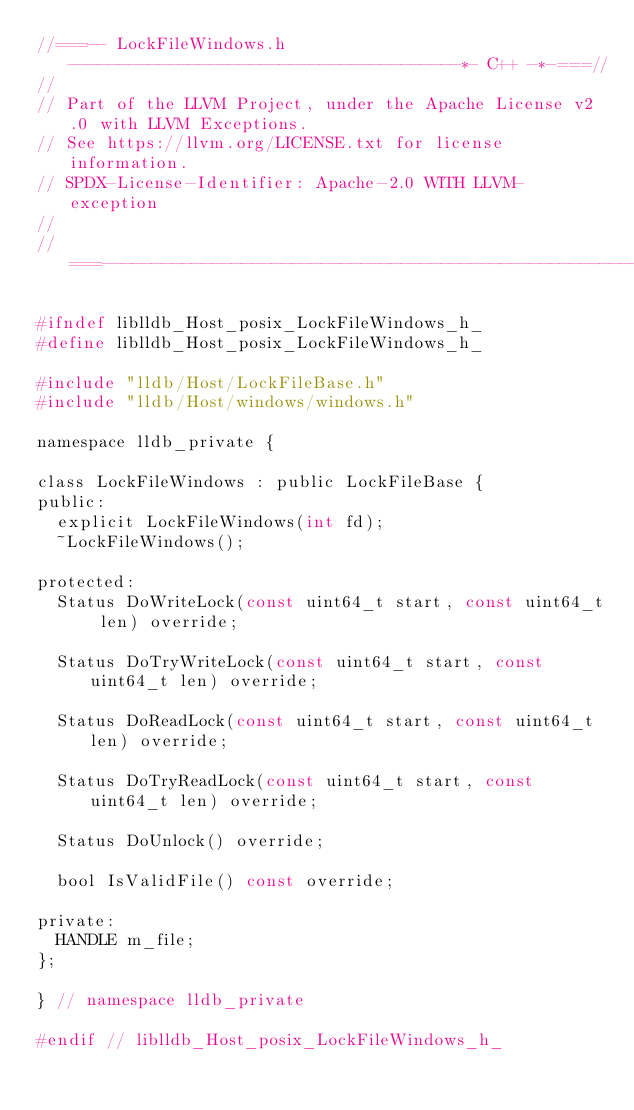<code> <loc_0><loc_0><loc_500><loc_500><_C_>//===-- LockFileWindows.h ---------------------------------------*- C++ -*-===//
//
// Part of the LLVM Project, under the Apache License v2.0 with LLVM Exceptions.
// See https://llvm.org/LICENSE.txt for license information.
// SPDX-License-Identifier: Apache-2.0 WITH LLVM-exception
//
//===----------------------------------------------------------------------===//

#ifndef liblldb_Host_posix_LockFileWindows_h_
#define liblldb_Host_posix_LockFileWindows_h_

#include "lldb/Host/LockFileBase.h"
#include "lldb/Host/windows/windows.h"

namespace lldb_private {

class LockFileWindows : public LockFileBase {
public:
  explicit LockFileWindows(int fd);
  ~LockFileWindows();

protected:
  Status DoWriteLock(const uint64_t start, const uint64_t len) override;

  Status DoTryWriteLock(const uint64_t start, const uint64_t len) override;

  Status DoReadLock(const uint64_t start, const uint64_t len) override;

  Status DoTryReadLock(const uint64_t start, const uint64_t len) override;

  Status DoUnlock() override;

  bool IsValidFile() const override;

private:
  HANDLE m_file;
};

} // namespace lldb_private

#endif // liblldb_Host_posix_LockFileWindows_h_
</code> 